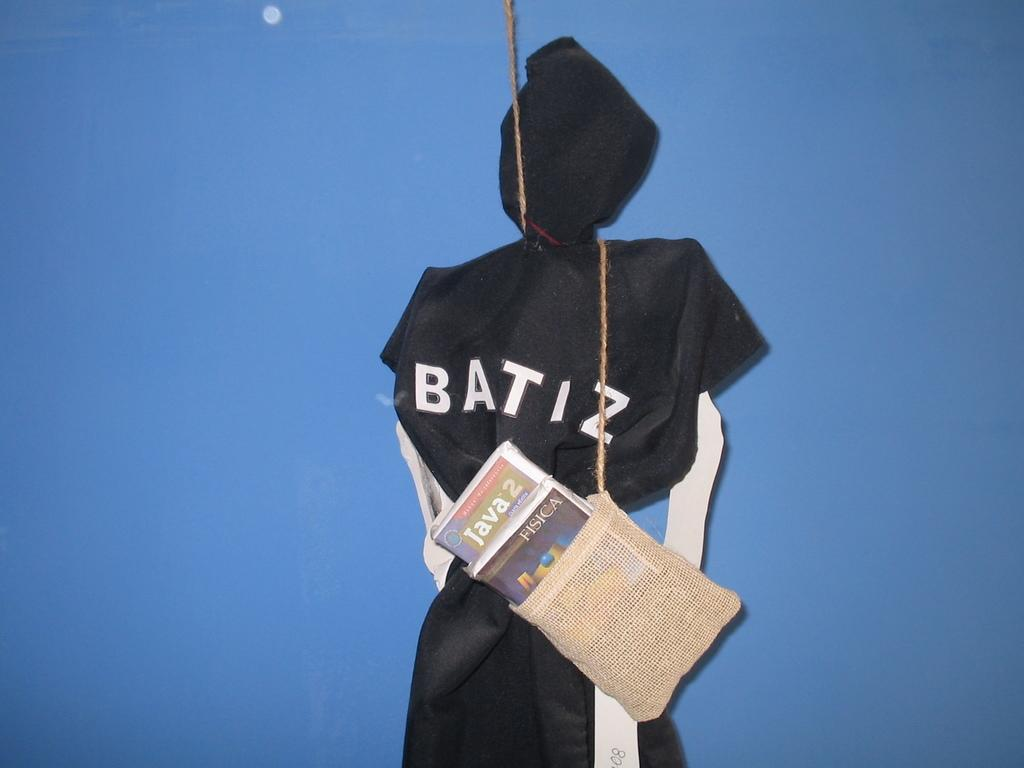What is the main subject in the image? There is a statue in the image. What is the statue wearing? The statue is wearing a black color dress. What else can be seen in the image besides the statue? There is a jute bag in the image, and it has books hanging from it. What is visible in the background of the image? There is a wall visible in the image. Can you hear the guitar playing in the image? There is no guitar present in the image, so it cannot be heard. Is there a sidewalk visible in the image? There is no sidewalk visible in the image; the wall is the primary background element. 